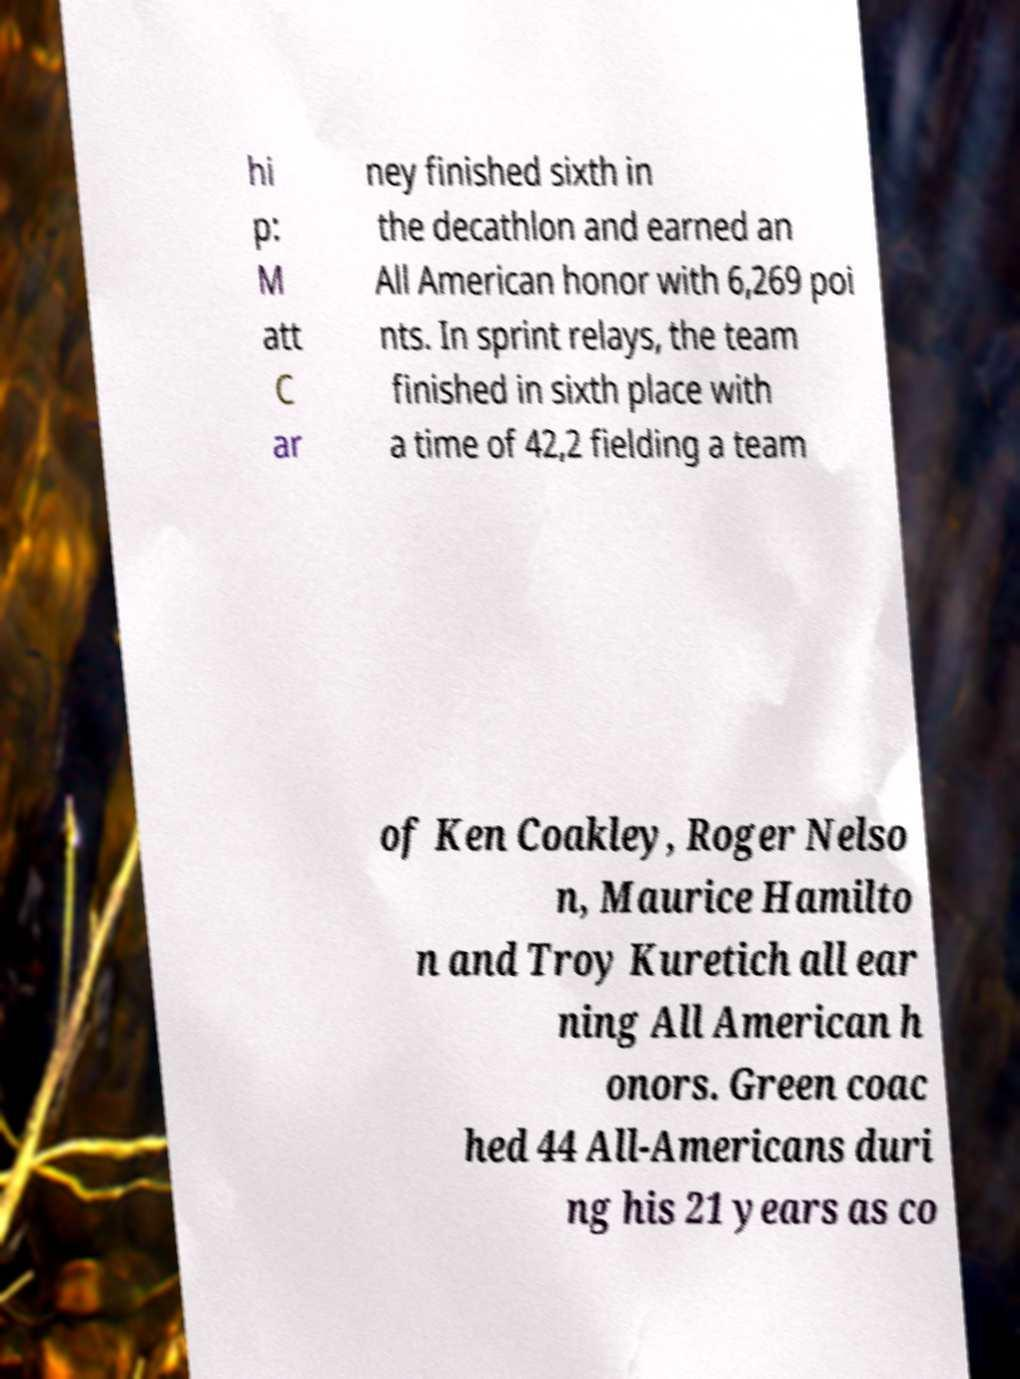Please read and relay the text visible in this image. What does it say? hi p: M att C ar ney finished sixth in the decathlon and earned an All American honor with 6,269 poi nts. In sprint relays, the team finished in sixth place with a time of 42,2 fielding a team of Ken Coakley, Roger Nelso n, Maurice Hamilto n and Troy Kuretich all ear ning All American h onors. Green coac hed 44 All-Americans duri ng his 21 years as co 